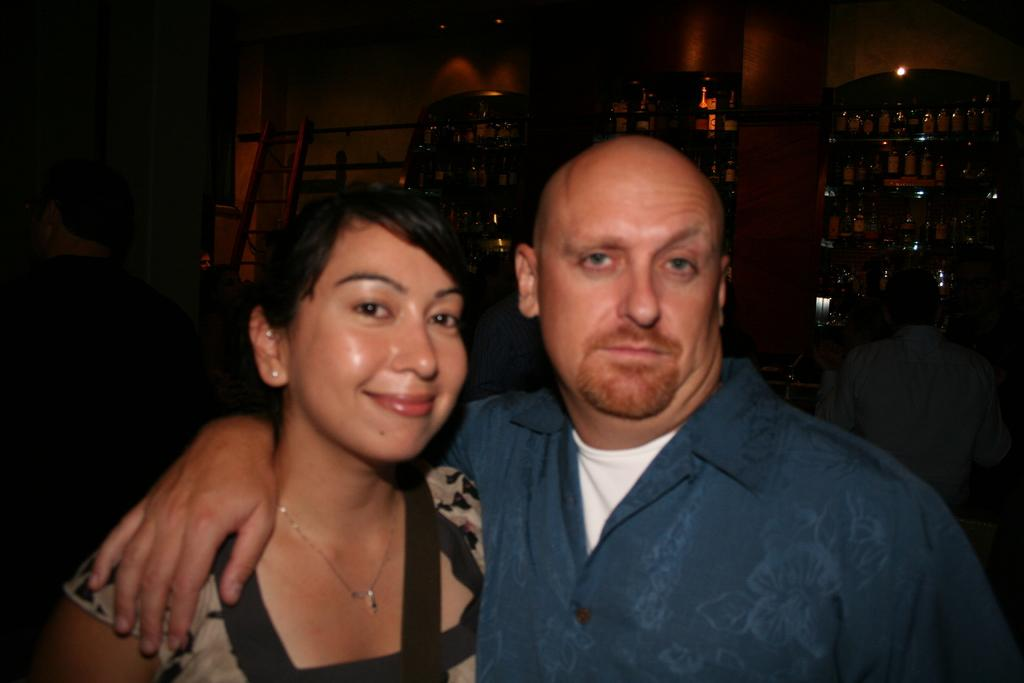What are the people in the front of the image doing? The persons standing in the front of the image are smiling. What can be seen in the background of the image? There are bottles and additional persons visible in the background of the image. What is the lighting condition in the image? There are lights visible in the image. How many snakes are slithering around the persons in the image? There are no snakes present in the image. What is the temperature in the image? The temperature cannot be determined from the image alone. 